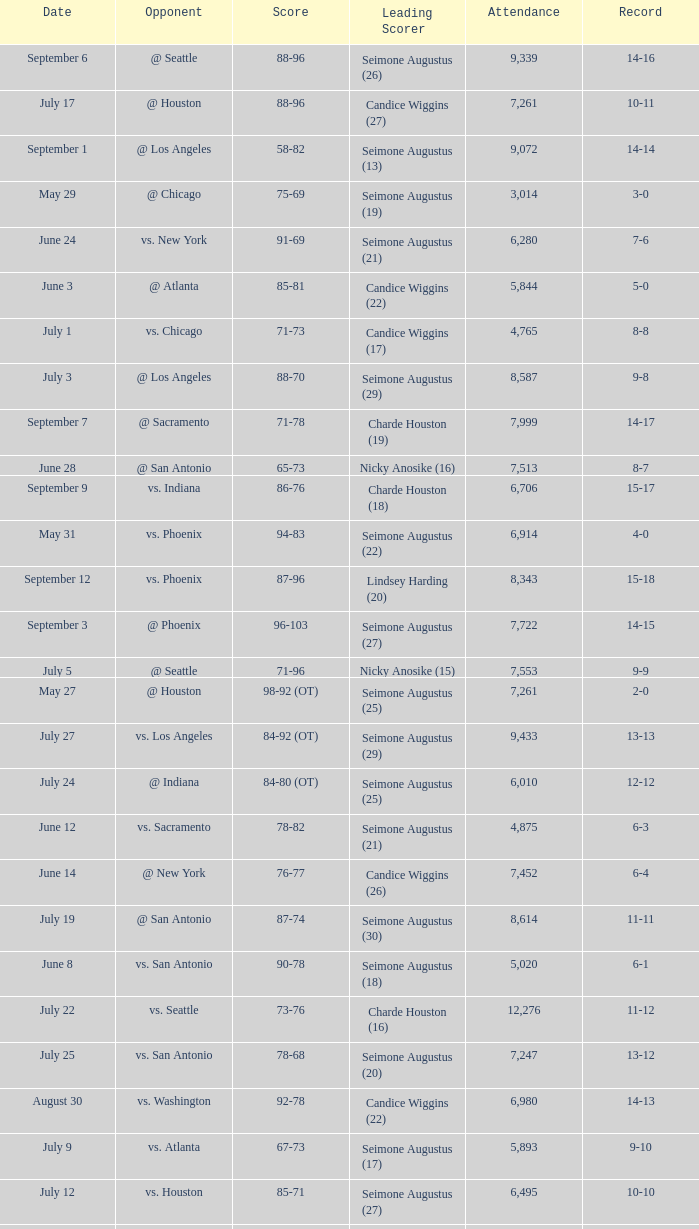Which Attendance has a Date of september 7? 7999.0. 